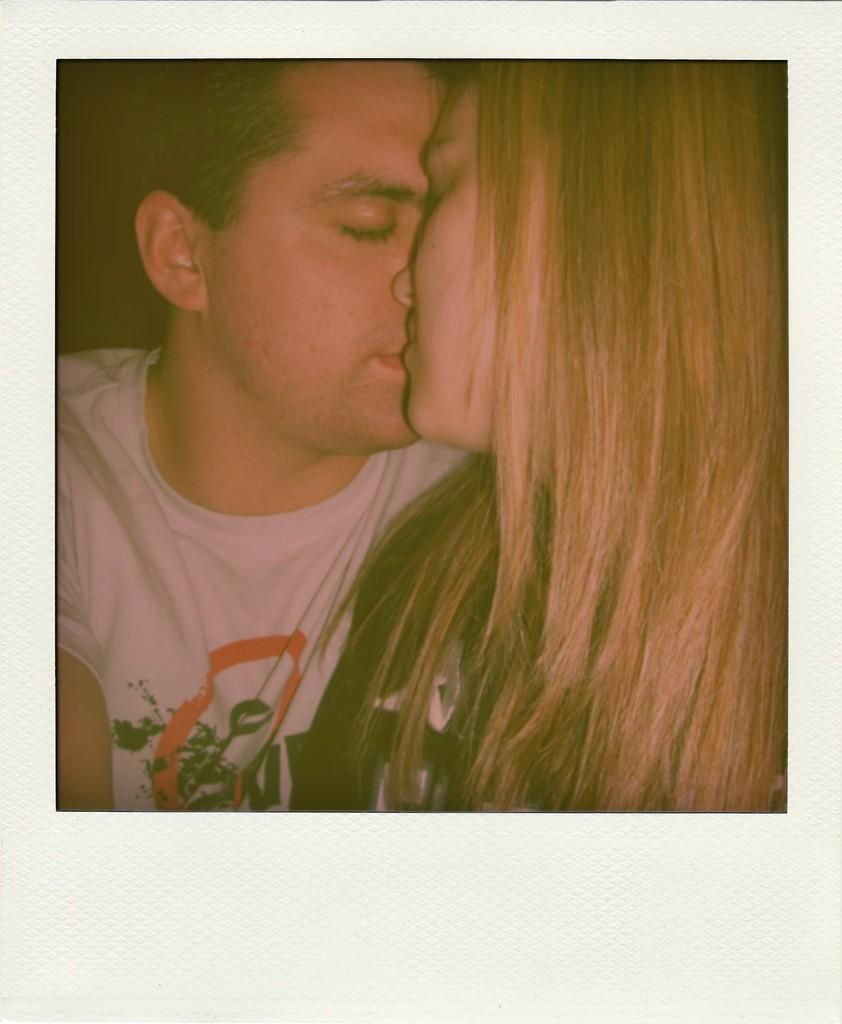How many people are present in the image? There are two people in the image, a man and a woman. What are the man and woman doing in the image? The man and woman are kissing each other. What type of jar is being used as a prop in the image? There is no jar present in the image; it features a man and a woman kissing each other. 